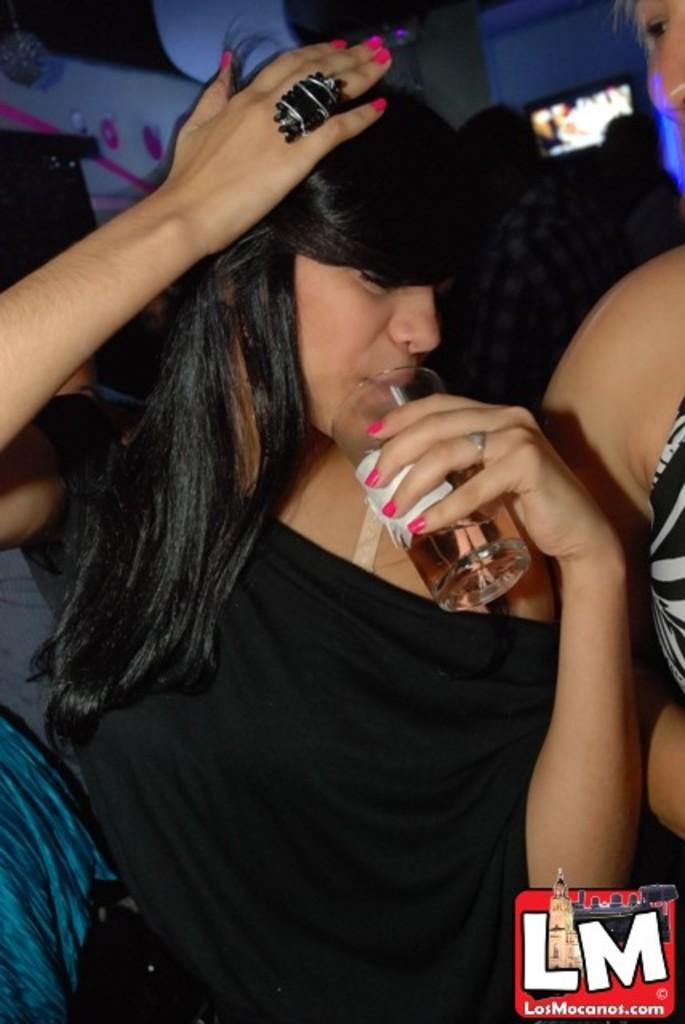How many people are in the image? There are people in the image, but the exact number is not specified. Can you describe the lady in the center of the image? The lady is standing in the center of the image and is holding a glass. What is present on the wall in the background of the image? There is a screen placed on the wall in the background of the image. Where is the shelf located in the image? There is no shelf present in the image. What type of geese can be seen interacting with the lady holding the glass? There are no geese present in the image; it only features people and a screen on the wall. 